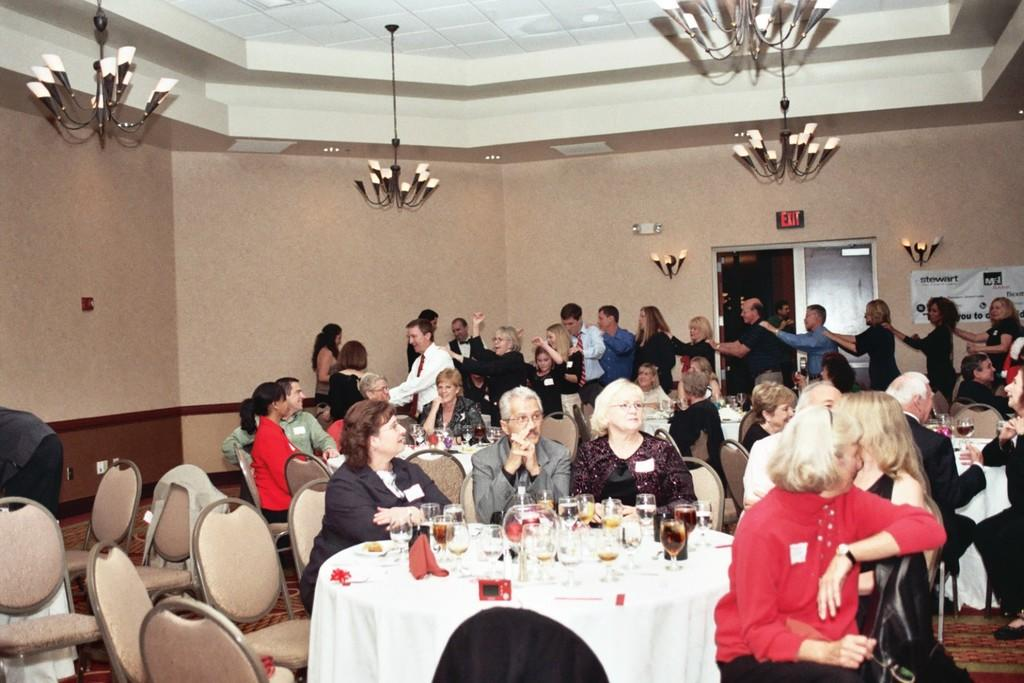What type of structure can be seen in the image? There is a wall in the image. What feature is present in the wall? There is a door in the image. What type of lighting is present in the image? There are chandeliers in the image. What type of furniture is present in the image? There are chairs and tables in the image. What are the people in the image doing? There are people standing and sitting in the image. What items can be seen on the table? There are glasses and plates on the table. What type of clouds can be seen in the image? There are no clouds present in the image; it is an indoor setting. What is the rate of digestion for the people in the image? There is no information about the people's digestion in the image. 